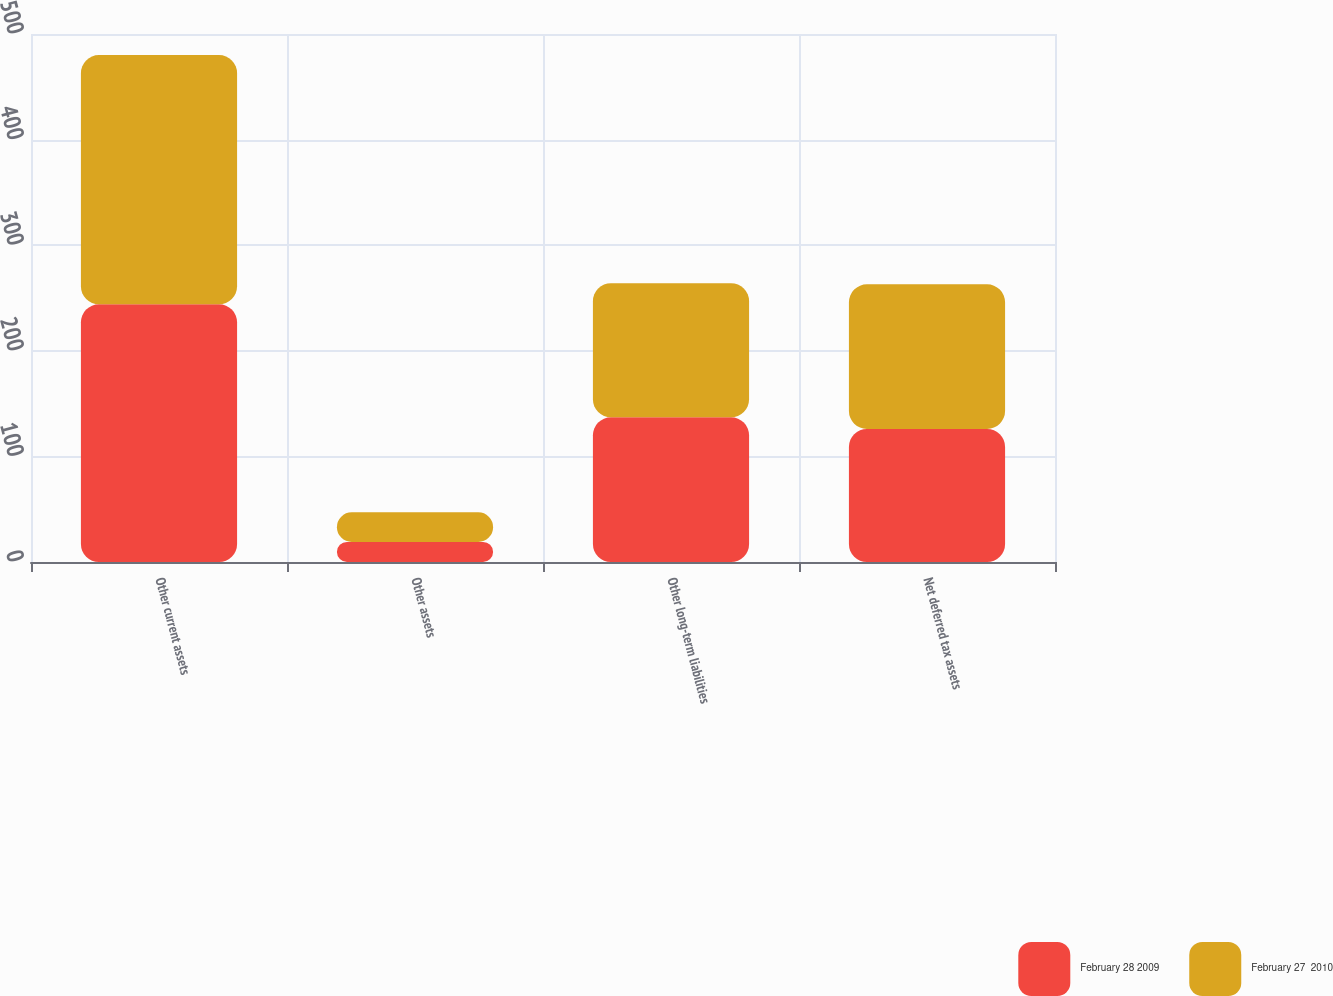Convert chart to OTSL. <chart><loc_0><loc_0><loc_500><loc_500><stacked_bar_chart><ecel><fcel>Other current assets<fcel>Other assets<fcel>Other long-term liabilities<fcel>Net deferred tax assets<nl><fcel>February 28 2009<fcel>244<fcel>19<fcel>137<fcel>126<nl><fcel>February 27  2010<fcel>236<fcel>28<fcel>127<fcel>137<nl></chart> 